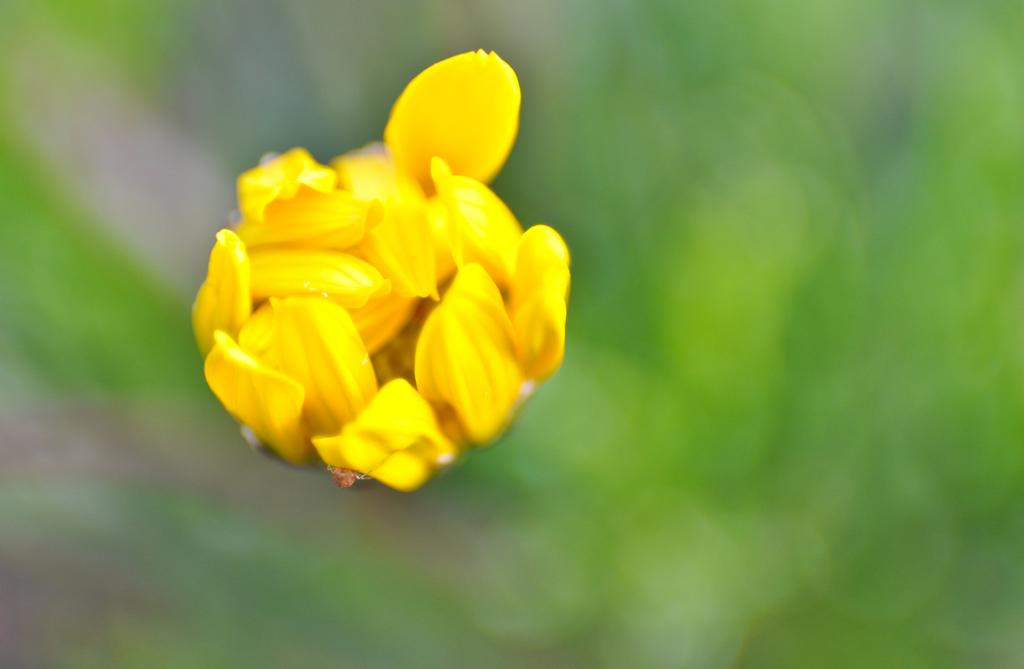What is the main subject of the image? There is a yellow flower in the middle of the image. Can you describe the background of the image? The background of the image is blurry. What is the name of the rat that is sitting on the paper in the image? There is no rat or paper present in the image; it features a yellow flower with a blurry background. 